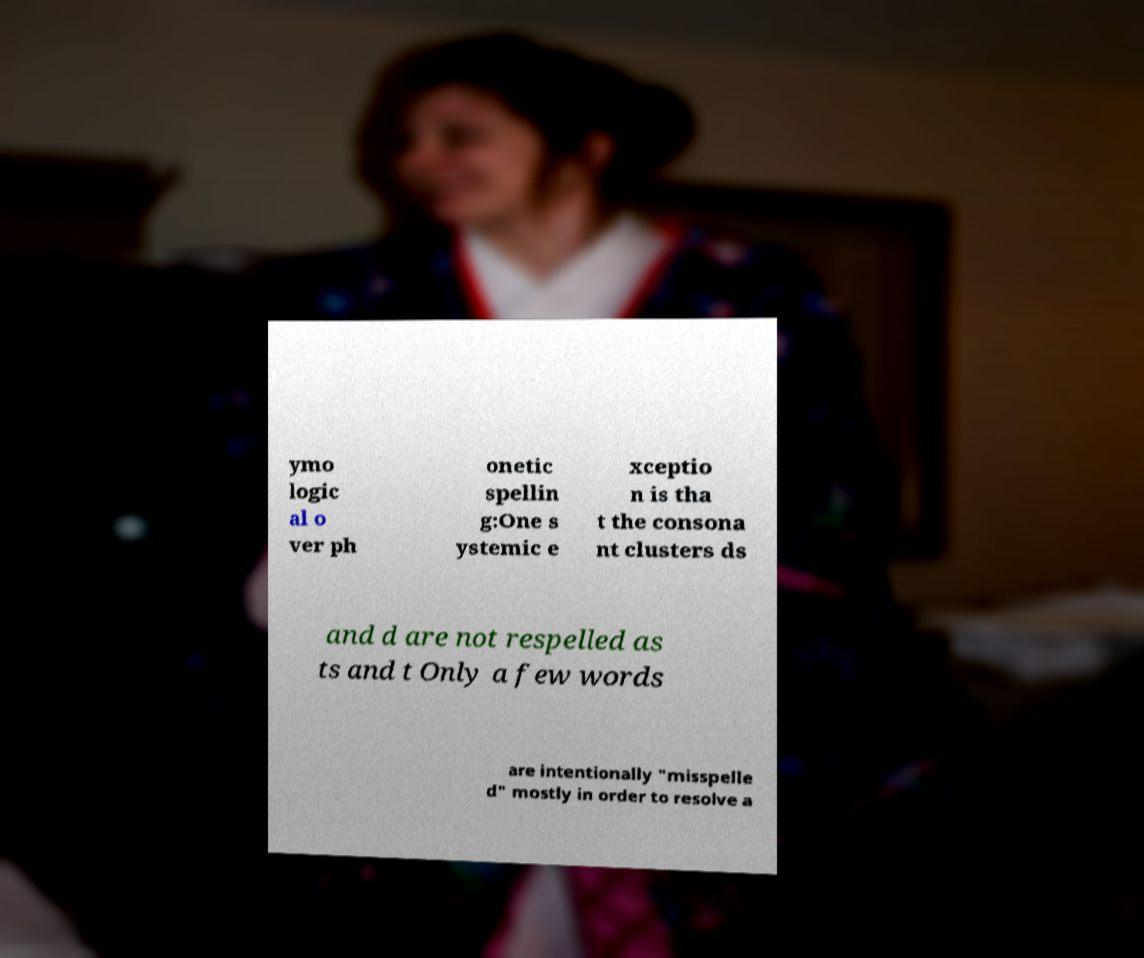What messages or text are displayed in this image? I need them in a readable, typed format. ymo logic al o ver ph onetic spellin g:One s ystemic e xceptio n is tha t the consona nt clusters ds and d are not respelled as ts and t Only a few words are intentionally "misspelle d" mostly in order to resolve a 